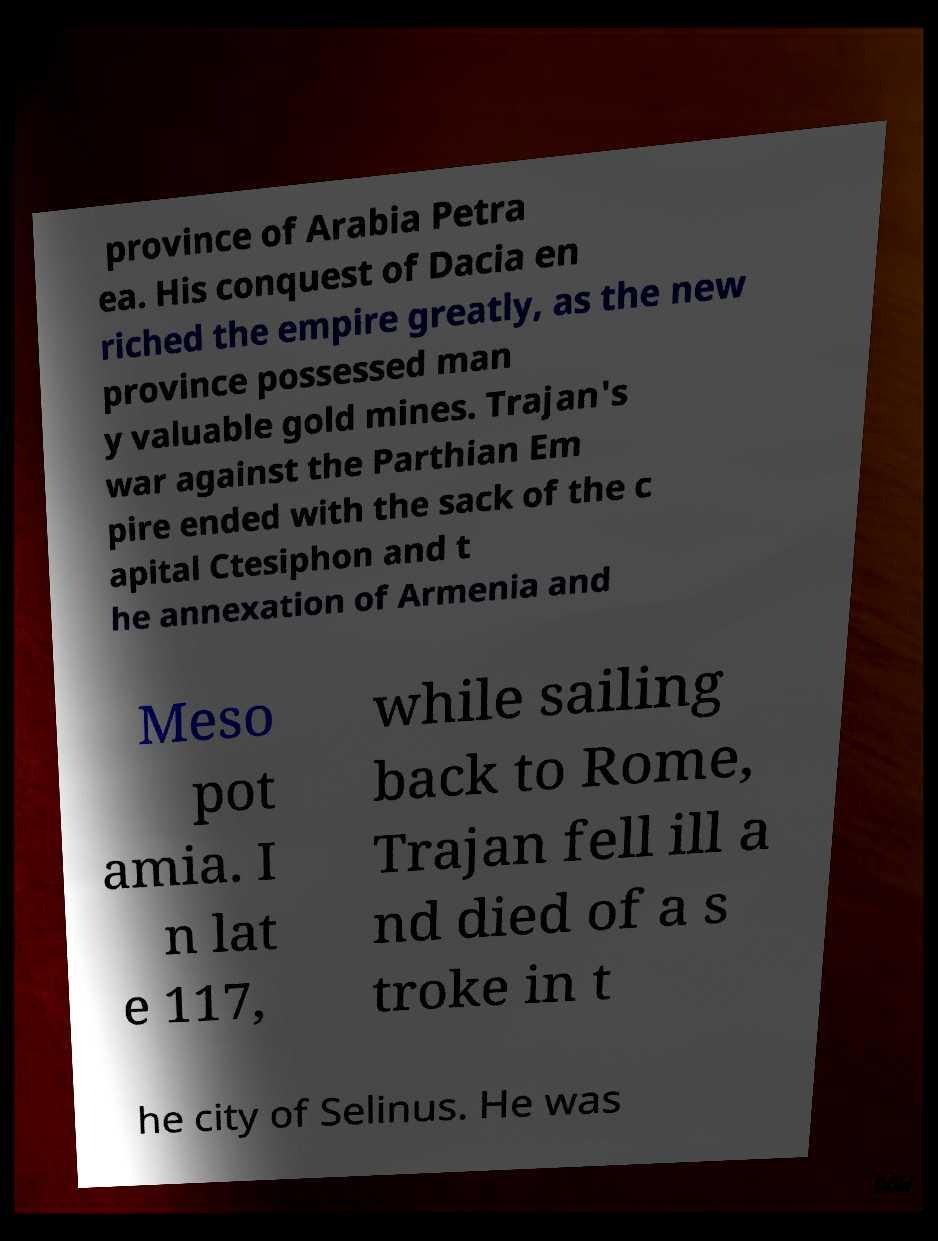Could you extract and type out the text from this image? province of Arabia Petra ea. His conquest of Dacia en riched the empire greatly, as the new province possessed man y valuable gold mines. Trajan's war against the Parthian Em pire ended with the sack of the c apital Ctesiphon and t he annexation of Armenia and Meso pot amia. I n lat e 117, while sailing back to Rome, Trajan fell ill a nd died of a s troke in t he city of Selinus. He was 